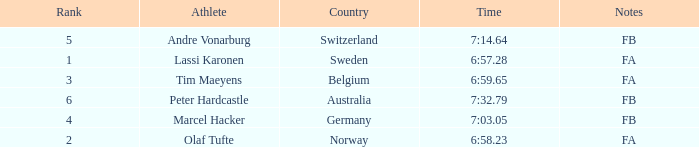What is the lowest rank for Andre Vonarburg, when the notes are FB? 5.0. 